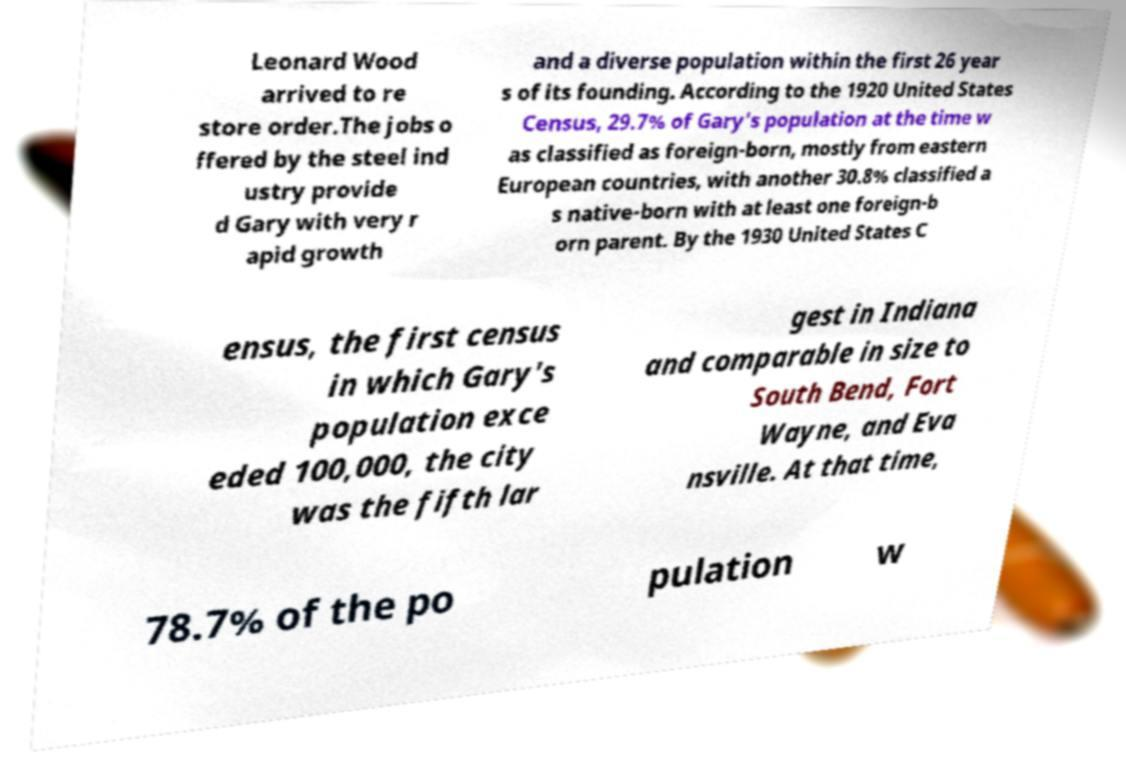I need the written content from this picture converted into text. Can you do that? Leonard Wood arrived to re store order.The jobs o ffered by the steel ind ustry provide d Gary with very r apid growth and a diverse population within the first 26 year s of its founding. According to the 1920 United States Census, 29.7% of Gary's population at the time w as classified as foreign-born, mostly from eastern European countries, with another 30.8% classified a s native-born with at least one foreign-b orn parent. By the 1930 United States C ensus, the first census in which Gary's population exce eded 100,000, the city was the fifth lar gest in Indiana and comparable in size to South Bend, Fort Wayne, and Eva nsville. At that time, 78.7% of the po pulation w 